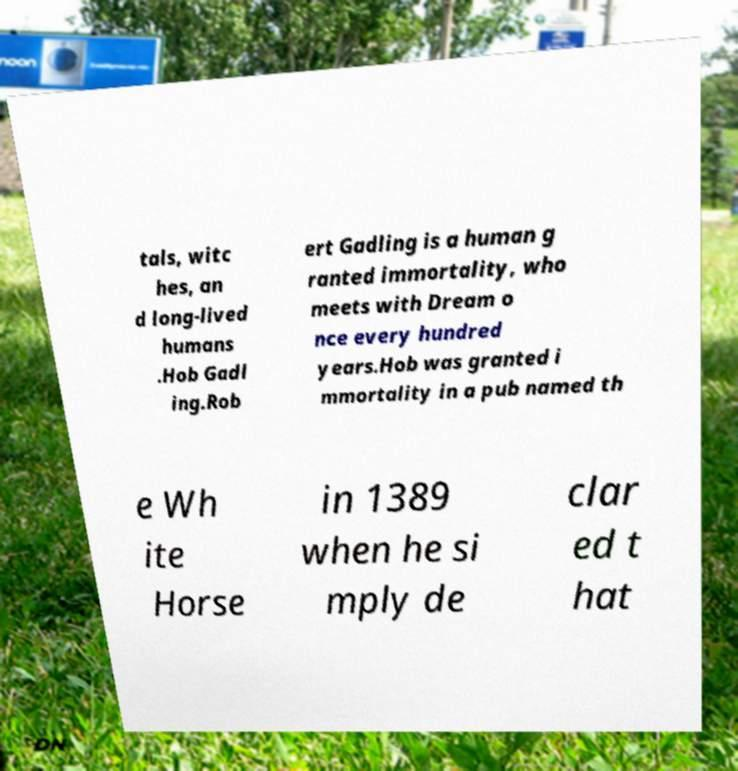For documentation purposes, I need the text within this image transcribed. Could you provide that? tals, witc hes, an d long-lived humans .Hob Gadl ing.Rob ert Gadling is a human g ranted immortality, who meets with Dream o nce every hundred years.Hob was granted i mmortality in a pub named th e Wh ite Horse in 1389 when he si mply de clar ed t hat 